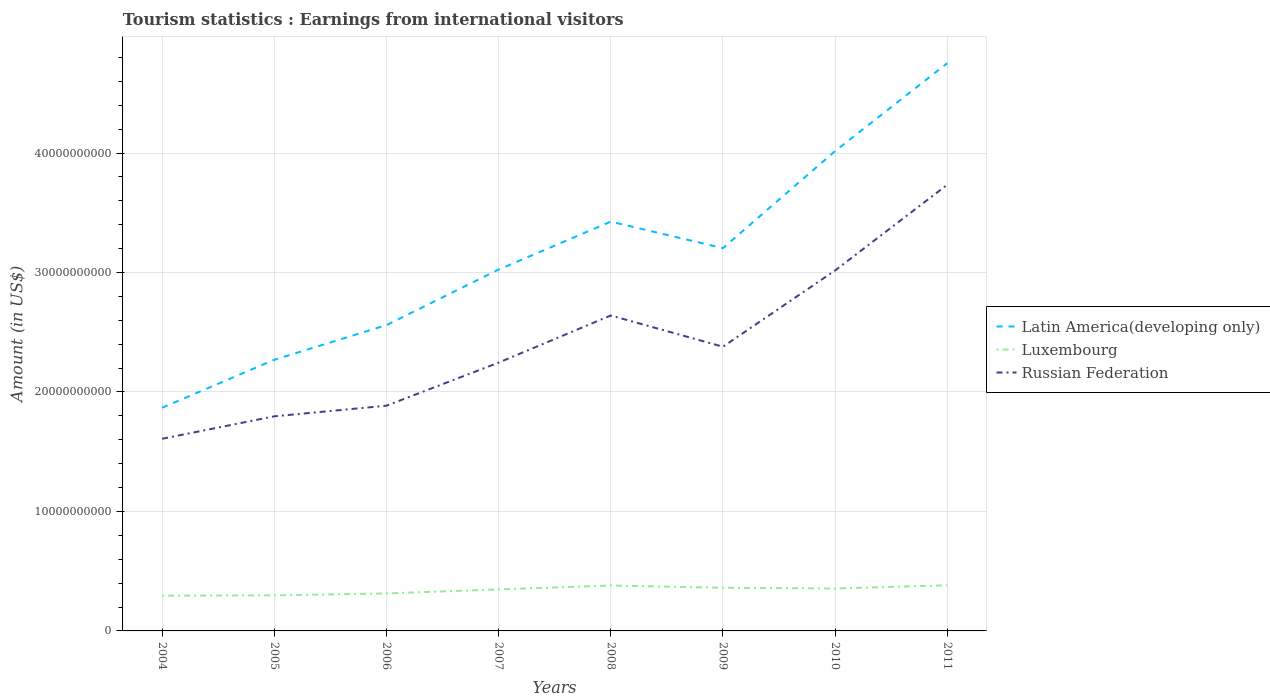How many different coloured lines are there?
Offer a terse response. 3. Across all years, what is the maximum earnings from international visitors in Luxembourg?
Keep it short and to the point. 2.95e+09. In which year was the earnings from international visitors in Russian Federation maximum?
Your answer should be compact. 2004. What is the total earnings from international visitors in Russian Federation in the graph?
Offer a terse response. -1.03e+1. What is the difference between the highest and the second highest earnings from international visitors in Latin America(developing only)?
Give a very brief answer. 2.88e+1. What is the difference between the highest and the lowest earnings from international visitors in Luxembourg?
Your answer should be compact. 5. Is the earnings from international visitors in Luxembourg strictly greater than the earnings from international visitors in Russian Federation over the years?
Offer a very short reply. Yes. How many years are there in the graph?
Offer a terse response. 8. What is the difference between two consecutive major ticks on the Y-axis?
Give a very brief answer. 1.00e+1. Does the graph contain grids?
Your answer should be very brief. Yes. How are the legend labels stacked?
Your answer should be compact. Vertical. What is the title of the graph?
Keep it short and to the point. Tourism statistics : Earnings from international visitors. Does "Andorra" appear as one of the legend labels in the graph?
Your answer should be compact. No. What is the Amount (in US$) of Latin America(developing only) in 2004?
Offer a terse response. 1.87e+1. What is the Amount (in US$) of Luxembourg in 2004?
Provide a succinct answer. 2.95e+09. What is the Amount (in US$) of Russian Federation in 2004?
Your answer should be compact. 1.61e+1. What is the Amount (in US$) in Latin America(developing only) in 2005?
Provide a short and direct response. 2.27e+1. What is the Amount (in US$) of Luxembourg in 2005?
Offer a very short reply. 2.98e+09. What is the Amount (in US$) in Russian Federation in 2005?
Provide a short and direct response. 1.80e+1. What is the Amount (in US$) of Latin America(developing only) in 2006?
Your response must be concise. 2.56e+1. What is the Amount (in US$) in Luxembourg in 2006?
Give a very brief answer. 3.14e+09. What is the Amount (in US$) in Russian Federation in 2006?
Provide a succinct answer. 1.88e+1. What is the Amount (in US$) in Latin America(developing only) in 2007?
Offer a terse response. 3.02e+1. What is the Amount (in US$) of Luxembourg in 2007?
Keep it short and to the point. 3.48e+09. What is the Amount (in US$) of Russian Federation in 2007?
Your answer should be very brief. 2.25e+1. What is the Amount (in US$) in Latin America(developing only) in 2008?
Ensure brevity in your answer.  3.43e+1. What is the Amount (in US$) of Luxembourg in 2008?
Your response must be concise. 3.80e+09. What is the Amount (in US$) of Russian Federation in 2008?
Make the answer very short. 2.64e+1. What is the Amount (in US$) of Latin America(developing only) in 2009?
Your answer should be very brief. 3.20e+1. What is the Amount (in US$) in Luxembourg in 2009?
Your answer should be very brief. 3.61e+09. What is the Amount (in US$) in Russian Federation in 2009?
Provide a succinct answer. 2.38e+1. What is the Amount (in US$) in Latin America(developing only) in 2010?
Provide a succinct answer. 4.02e+1. What is the Amount (in US$) in Luxembourg in 2010?
Your response must be concise. 3.55e+09. What is the Amount (in US$) in Russian Federation in 2010?
Your response must be concise. 3.02e+1. What is the Amount (in US$) in Latin America(developing only) in 2011?
Make the answer very short. 4.75e+1. What is the Amount (in US$) of Luxembourg in 2011?
Ensure brevity in your answer.  3.82e+09. What is the Amount (in US$) of Russian Federation in 2011?
Provide a succinct answer. 3.73e+1. Across all years, what is the maximum Amount (in US$) of Latin America(developing only)?
Provide a short and direct response. 4.75e+1. Across all years, what is the maximum Amount (in US$) in Luxembourg?
Offer a very short reply. 3.82e+09. Across all years, what is the maximum Amount (in US$) of Russian Federation?
Provide a succinct answer. 3.73e+1. Across all years, what is the minimum Amount (in US$) in Latin America(developing only)?
Your response must be concise. 1.87e+1. Across all years, what is the minimum Amount (in US$) of Luxembourg?
Provide a short and direct response. 2.95e+09. Across all years, what is the minimum Amount (in US$) of Russian Federation?
Provide a succinct answer. 1.61e+1. What is the total Amount (in US$) in Latin America(developing only) in the graph?
Your answer should be very brief. 2.51e+11. What is the total Amount (in US$) of Luxembourg in the graph?
Your answer should be very brief. 2.73e+1. What is the total Amount (in US$) of Russian Federation in the graph?
Your answer should be compact. 1.93e+11. What is the difference between the Amount (in US$) of Latin America(developing only) in 2004 and that in 2005?
Keep it short and to the point. -4.01e+09. What is the difference between the Amount (in US$) in Luxembourg in 2004 and that in 2005?
Provide a short and direct response. -2.70e+07. What is the difference between the Amount (in US$) in Russian Federation in 2004 and that in 2005?
Your answer should be very brief. -1.88e+09. What is the difference between the Amount (in US$) of Latin America(developing only) in 2004 and that in 2006?
Ensure brevity in your answer.  -6.91e+09. What is the difference between the Amount (in US$) of Luxembourg in 2004 and that in 2006?
Give a very brief answer. -1.88e+08. What is the difference between the Amount (in US$) in Russian Federation in 2004 and that in 2006?
Ensure brevity in your answer.  -2.77e+09. What is the difference between the Amount (in US$) of Latin America(developing only) in 2004 and that in 2007?
Keep it short and to the point. -1.16e+1. What is the difference between the Amount (in US$) in Luxembourg in 2004 and that in 2007?
Offer a very short reply. -5.26e+08. What is the difference between the Amount (in US$) in Russian Federation in 2004 and that in 2007?
Give a very brief answer. -6.37e+09. What is the difference between the Amount (in US$) of Latin America(developing only) in 2004 and that in 2008?
Your answer should be compact. -1.56e+1. What is the difference between the Amount (in US$) in Luxembourg in 2004 and that in 2008?
Make the answer very short. -8.51e+08. What is the difference between the Amount (in US$) in Russian Federation in 2004 and that in 2008?
Offer a terse response. -1.03e+1. What is the difference between the Amount (in US$) in Latin America(developing only) in 2004 and that in 2009?
Keep it short and to the point. -1.34e+1. What is the difference between the Amount (in US$) of Luxembourg in 2004 and that in 2009?
Give a very brief answer. -6.62e+08. What is the difference between the Amount (in US$) in Russian Federation in 2004 and that in 2009?
Offer a very short reply. -7.70e+09. What is the difference between the Amount (in US$) in Latin America(developing only) in 2004 and that in 2010?
Keep it short and to the point. -2.15e+1. What is the difference between the Amount (in US$) in Luxembourg in 2004 and that in 2010?
Your response must be concise. -5.99e+08. What is the difference between the Amount (in US$) in Russian Federation in 2004 and that in 2010?
Your answer should be compact. -1.41e+1. What is the difference between the Amount (in US$) of Latin America(developing only) in 2004 and that in 2011?
Give a very brief answer. -2.88e+1. What is the difference between the Amount (in US$) in Luxembourg in 2004 and that in 2011?
Provide a succinct answer. -8.72e+08. What is the difference between the Amount (in US$) of Russian Federation in 2004 and that in 2011?
Your answer should be compact. -2.13e+1. What is the difference between the Amount (in US$) in Latin America(developing only) in 2005 and that in 2006?
Provide a succinct answer. -2.90e+09. What is the difference between the Amount (in US$) of Luxembourg in 2005 and that in 2006?
Provide a succinct answer. -1.61e+08. What is the difference between the Amount (in US$) in Russian Federation in 2005 and that in 2006?
Provide a short and direct response. -8.87e+08. What is the difference between the Amount (in US$) in Latin America(developing only) in 2005 and that in 2007?
Give a very brief answer. -7.55e+09. What is the difference between the Amount (in US$) of Luxembourg in 2005 and that in 2007?
Offer a very short reply. -4.99e+08. What is the difference between the Amount (in US$) of Russian Federation in 2005 and that in 2007?
Ensure brevity in your answer.  -4.49e+09. What is the difference between the Amount (in US$) of Latin America(developing only) in 2005 and that in 2008?
Give a very brief answer. -1.16e+1. What is the difference between the Amount (in US$) of Luxembourg in 2005 and that in 2008?
Make the answer very short. -8.24e+08. What is the difference between the Amount (in US$) in Russian Federation in 2005 and that in 2008?
Provide a short and direct response. -8.44e+09. What is the difference between the Amount (in US$) in Latin America(developing only) in 2005 and that in 2009?
Keep it short and to the point. -9.34e+09. What is the difference between the Amount (in US$) in Luxembourg in 2005 and that in 2009?
Your answer should be compact. -6.35e+08. What is the difference between the Amount (in US$) in Russian Federation in 2005 and that in 2009?
Give a very brief answer. -5.82e+09. What is the difference between the Amount (in US$) in Latin America(developing only) in 2005 and that in 2010?
Offer a very short reply. -1.75e+1. What is the difference between the Amount (in US$) of Luxembourg in 2005 and that in 2010?
Provide a succinct answer. -5.72e+08. What is the difference between the Amount (in US$) of Russian Federation in 2005 and that in 2010?
Keep it short and to the point. -1.22e+1. What is the difference between the Amount (in US$) in Latin America(developing only) in 2005 and that in 2011?
Your answer should be compact. -2.48e+1. What is the difference between the Amount (in US$) of Luxembourg in 2005 and that in 2011?
Ensure brevity in your answer.  -8.45e+08. What is the difference between the Amount (in US$) in Russian Federation in 2005 and that in 2011?
Offer a very short reply. -1.94e+1. What is the difference between the Amount (in US$) of Latin America(developing only) in 2006 and that in 2007?
Keep it short and to the point. -4.65e+09. What is the difference between the Amount (in US$) of Luxembourg in 2006 and that in 2007?
Ensure brevity in your answer.  -3.38e+08. What is the difference between the Amount (in US$) in Russian Federation in 2006 and that in 2007?
Your response must be concise. -3.61e+09. What is the difference between the Amount (in US$) in Latin America(developing only) in 2006 and that in 2008?
Provide a succinct answer. -8.66e+09. What is the difference between the Amount (in US$) of Luxembourg in 2006 and that in 2008?
Offer a terse response. -6.63e+08. What is the difference between the Amount (in US$) in Russian Federation in 2006 and that in 2008?
Offer a terse response. -7.55e+09. What is the difference between the Amount (in US$) in Latin America(developing only) in 2006 and that in 2009?
Keep it short and to the point. -6.44e+09. What is the difference between the Amount (in US$) of Luxembourg in 2006 and that in 2009?
Make the answer very short. -4.74e+08. What is the difference between the Amount (in US$) of Russian Federation in 2006 and that in 2009?
Keep it short and to the point. -4.94e+09. What is the difference between the Amount (in US$) in Latin America(developing only) in 2006 and that in 2010?
Provide a short and direct response. -1.46e+1. What is the difference between the Amount (in US$) of Luxembourg in 2006 and that in 2010?
Provide a short and direct response. -4.11e+08. What is the difference between the Amount (in US$) of Russian Federation in 2006 and that in 2010?
Give a very brief answer. -1.13e+1. What is the difference between the Amount (in US$) in Latin America(developing only) in 2006 and that in 2011?
Give a very brief answer. -2.19e+1. What is the difference between the Amount (in US$) of Luxembourg in 2006 and that in 2011?
Offer a terse response. -6.84e+08. What is the difference between the Amount (in US$) of Russian Federation in 2006 and that in 2011?
Your answer should be very brief. -1.85e+1. What is the difference between the Amount (in US$) in Latin America(developing only) in 2007 and that in 2008?
Your response must be concise. -4.01e+09. What is the difference between the Amount (in US$) of Luxembourg in 2007 and that in 2008?
Make the answer very short. -3.25e+08. What is the difference between the Amount (in US$) of Russian Federation in 2007 and that in 2008?
Offer a terse response. -3.94e+09. What is the difference between the Amount (in US$) in Latin America(developing only) in 2007 and that in 2009?
Ensure brevity in your answer.  -1.79e+09. What is the difference between the Amount (in US$) in Luxembourg in 2007 and that in 2009?
Offer a very short reply. -1.36e+08. What is the difference between the Amount (in US$) in Russian Federation in 2007 and that in 2009?
Offer a terse response. -1.33e+09. What is the difference between the Amount (in US$) of Latin America(developing only) in 2007 and that in 2010?
Offer a terse response. -9.91e+09. What is the difference between the Amount (in US$) of Luxembourg in 2007 and that in 2010?
Keep it short and to the point. -7.30e+07. What is the difference between the Amount (in US$) of Russian Federation in 2007 and that in 2010?
Make the answer very short. -7.71e+09. What is the difference between the Amount (in US$) in Latin America(developing only) in 2007 and that in 2011?
Give a very brief answer. -1.73e+1. What is the difference between the Amount (in US$) in Luxembourg in 2007 and that in 2011?
Keep it short and to the point. -3.46e+08. What is the difference between the Amount (in US$) in Russian Federation in 2007 and that in 2011?
Your response must be concise. -1.49e+1. What is the difference between the Amount (in US$) in Latin America(developing only) in 2008 and that in 2009?
Provide a succinct answer. 2.22e+09. What is the difference between the Amount (in US$) of Luxembourg in 2008 and that in 2009?
Your answer should be compact. 1.89e+08. What is the difference between the Amount (in US$) in Russian Federation in 2008 and that in 2009?
Give a very brief answer. 2.62e+09. What is the difference between the Amount (in US$) in Latin America(developing only) in 2008 and that in 2010?
Your response must be concise. -5.90e+09. What is the difference between the Amount (in US$) in Luxembourg in 2008 and that in 2010?
Your response must be concise. 2.52e+08. What is the difference between the Amount (in US$) in Russian Federation in 2008 and that in 2010?
Give a very brief answer. -3.77e+09. What is the difference between the Amount (in US$) in Latin America(developing only) in 2008 and that in 2011?
Offer a terse response. -1.33e+1. What is the difference between the Amount (in US$) in Luxembourg in 2008 and that in 2011?
Offer a terse response. -2.10e+07. What is the difference between the Amount (in US$) in Russian Federation in 2008 and that in 2011?
Your answer should be very brief. -1.09e+1. What is the difference between the Amount (in US$) in Latin America(developing only) in 2009 and that in 2010?
Offer a terse response. -8.12e+09. What is the difference between the Amount (in US$) of Luxembourg in 2009 and that in 2010?
Offer a very short reply. 6.30e+07. What is the difference between the Amount (in US$) in Russian Federation in 2009 and that in 2010?
Provide a succinct answer. -6.38e+09. What is the difference between the Amount (in US$) of Latin America(developing only) in 2009 and that in 2011?
Provide a succinct answer. -1.55e+1. What is the difference between the Amount (in US$) of Luxembourg in 2009 and that in 2011?
Give a very brief answer. -2.10e+08. What is the difference between the Amount (in US$) of Russian Federation in 2009 and that in 2011?
Offer a very short reply. -1.36e+1. What is the difference between the Amount (in US$) of Latin America(developing only) in 2010 and that in 2011?
Ensure brevity in your answer.  -7.36e+09. What is the difference between the Amount (in US$) of Luxembourg in 2010 and that in 2011?
Make the answer very short. -2.73e+08. What is the difference between the Amount (in US$) in Russian Federation in 2010 and that in 2011?
Give a very brief answer. -7.17e+09. What is the difference between the Amount (in US$) in Latin America(developing only) in 2004 and the Amount (in US$) in Luxembourg in 2005?
Your response must be concise. 1.57e+1. What is the difference between the Amount (in US$) of Latin America(developing only) in 2004 and the Amount (in US$) of Russian Federation in 2005?
Make the answer very short. 7.19e+08. What is the difference between the Amount (in US$) in Luxembourg in 2004 and the Amount (in US$) in Russian Federation in 2005?
Provide a succinct answer. -1.50e+1. What is the difference between the Amount (in US$) of Latin America(developing only) in 2004 and the Amount (in US$) of Luxembourg in 2006?
Make the answer very short. 1.55e+1. What is the difference between the Amount (in US$) in Latin America(developing only) in 2004 and the Amount (in US$) in Russian Federation in 2006?
Provide a succinct answer. -1.68e+08. What is the difference between the Amount (in US$) in Luxembourg in 2004 and the Amount (in US$) in Russian Federation in 2006?
Your response must be concise. -1.59e+1. What is the difference between the Amount (in US$) of Latin America(developing only) in 2004 and the Amount (in US$) of Luxembourg in 2007?
Make the answer very short. 1.52e+1. What is the difference between the Amount (in US$) of Latin America(developing only) in 2004 and the Amount (in US$) of Russian Federation in 2007?
Ensure brevity in your answer.  -3.77e+09. What is the difference between the Amount (in US$) of Luxembourg in 2004 and the Amount (in US$) of Russian Federation in 2007?
Ensure brevity in your answer.  -1.95e+1. What is the difference between the Amount (in US$) of Latin America(developing only) in 2004 and the Amount (in US$) of Luxembourg in 2008?
Your answer should be compact. 1.49e+1. What is the difference between the Amount (in US$) in Latin America(developing only) in 2004 and the Amount (in US$) in Russian Federation in 2008?
Offer a very short reply. -7.72e+09. What is the difference between the Amount (in US$) in Luxembourg in 2004 and the Amount (in US$) in Russian Federation in 2008?
Provide a short and direct response. -2.35e+1. What is the difference between the Amount (in US$) of Latin America(developing only) in 2004 and the Amount (in US$) of Luxembourg in 2009?
Your response must be concise. 1.51e+1. What is the difference between the Amount (in US$) in Latin America(developing only) in 2004 and the Amount (in US$) in Russian Federation in 2009?
Offer a very short reply. -5.10e+09. What is the difference between the Amount (in US$) in Luxembourg in 2004 and the Amount (in US$) in Russian Federation in 2009?
Make the answer very short. -2.08e+1. What is the difference between the Amount (in US$) in Latin America(developing only) in 2004 and the Amount (in US$) in Luxembourg in 2010?
Provide a succinct answer. 1.51e+1. What is the difference between the Amount (in US$) in Latin America(developing only) in 2004 and the Amount (in US$) in Russian Federation in 2010?
Provide a short and direct response. -1.15e+1. What is the difference between the Amount (in US$) in Luxembourg in 2004 and the Amount (in US$) in Russian Federation in 2010?
Make the answer very short. -2.72e+1. What is the difference between the Amount (in US$) in Latin America(developing only) in 2004 and the Amount (in US$) in Luxembourg in 2011?
Keep it short and to the point. 1.49e+1. What is the difference between the Amount (in US$) of Latin America(developing only) in 2004 and the Amount (in US$) of Russian Federation in 2011?
Your answer should be very brief. -1.87e+1. What is the difference between the Amount (in US$) of Luxembourg in 2004 and the Amount (in US$) of Russian Federation in 2011?
Your answer should be very brief. -3.44e+1. What is the difference between the Amount (in US$) of Latin America(developing only) in 2005 and the Amount (in US$) of Luxembourg in 2006?
Ensure brevity in your answer.  1.96e+1. What is the difference between the Amount (in US$) of Latin America(developing only) in 2005 and the Amount (in US$) of Russian Federation in 2006?
Keep it short and to the point. 3.84e+09. What is the difference between the Amount (in US$) in Luxembourg in 2005 and the Amount (in US$) in Russian Federation in 2006?
Offer a terse response. -1.59e+1. What is the difference between the Amount (in US$) in Latin America(developing only) in 2005 and the Amount (in US$) in Luxembourg in 2007?
Your response must be concise. 1.92e+1. What is the difference between the Amount (in US$) in Latin America(developing only) in 2005 and the Amount (in US$) in Russian Federation in 2007?
Provide a short and direct response. 2.37e+08. What is the difference between the Amount (in US$) in Luxembourg in 2005 and the Amount (in US$) in Russian Federation in 2007?
Your response must be concise. -1.95e+1. What is the difference between the Amount (in US$) in Latin America(developing only) in 2005 and the Amount (in US$) in Luxembourg in 2008?
Ensure brevity in your answer.  1.89e+1. What is the difference between the Amount (in US$) of Latin America(developing only) in 2005 and the Amount (in US$) of Russian Federation in 2008?
Ensure brevity in your answer.  -3.71e+09. What is the difference between the Amount (in US$) in Luxembourg in 2005 and the Amount (in US$) in Russian Federation in 2008?
Your answer should be very brief. -2.34e+1. What is the difference between the Amount (in US$) of Latin America(developing only) in 2005 and the Amount (in US$) of Luxembourg in 2009?
Your answer should be very brief. 1.91e+1. What is the difference between the Amount (in US$) of Latin America(developing only) in 2005 and the Amount (in US$) of Russian Federation in 2009?
Your answer should be compact. -1.09e+09. What is the difference between the Amount (in US$) in Luxembourg in 2005 and the Amount (in US$) in Russian Federation in 2009?
Offer a terse response. -2.08e+1. What is the difference between the Amount (in US$) of Latin America(developing only) in 2005 and the Amount (in US$) of Luxembourg in 2010?
Your answer should be compact. 1.91e+1. What is the difference between the Amount (in US$) in Latin America(developing only) in 2005 and the Amount (in US$) in Russian Federation in 2010?
Offer a very short reply. -7.48e+09. What is the difference between the Amount (in US$) in Luxembourg in 2005 and the Amount (in US$) in Russian Federation in 2010?
Ensure brevity in your answer.  -2.72e+1. What is the difference between the Amount (in US$) in Latin America(developing only) in 2005 and the Amount (in US$) in Luxembourg in 2011?
Make the answer very short. 1.89e+1. What is the difference between the Amount (in US$) in Latin America(developing only) in 2005 and the Amount (in US$) in Russian Federation in 2011?
Keep it short and to the point. -1.46e+1. What is the difference between the Amount (in US$) in Luxembourg in 2005 and the Amount (in US$) in Russian Federation in 2011?
Make the answer very short. -3.44e+1. What is the difference between the Amount (in US$) in Latin America(developing only) in 2006 and the Amount (in US$) in Luxembourg in 2007?
Ensure brevity in your answer.  2.21e+1. What is the difference between the Amount (in US$) of Latin America(developing only) in 2006 and the Amount (in US$) of Russian Federation in 2007?
Keep it short and to the point. 3.14e+09. What is the difference between the Amount (in US$) in Luxembourg in 2006 and the Amount (in US$) in Russian Federation in 2007?
Provide a succinct answer. -1.93e+1. What is the difference between the Amount (in US$) of Latin America(developing only) in 2006 and the Amount (in US$) of Luxembourg in 2008?
Your response must be concise. 2.18e+1. What is the difference between the Amount (in US$) of Latin America(developing only) in 2006 and the Amount (in US$) of Russian Federation in 2008?
Give a very brief answer. -8.07e+08. What is the difference between the Amount (in US$) in Luxembourg in 2006 and the Amount (in US$) in Russian Federation in 2008?
Give a very brief answer. -2.33e+1. What is the difference between the Amount (in US$) of Latin America(developing only) in 2006 and the Amount (in US$) of Luxembourg in 2009?
Give a very brief answer. 2.20e+1. What is the difference between the Amount (in US$) of Latin America(developing only) in 2006 and the Amount (in US$) of Russian Federation in 2009?
Your answer should be very brief. 1.81e+09. What is the difference between the Amount (in US$) in Luxembourg in 2006 and the Amount (in US$) in Russian Federation in 2009?
Give a very brief answer. -2.06e+1. What is the difference between the Amount (in US$) of Latin America(developing only) in 2006 and the Amount (in US$) of Luxembourg in 2010?
Keep it short and to the point. 2.20e+1. What is the difference between the Amount (in US$) in Latin America(developing only) in 2006 and the Amount (in US$) in Russian Federation in 2010?
Provide a succinct answer. -4.58e+09. What is the difference between the Amount (in US$) in Luxembourg in 2006 and the Amount (in US$) in Russian Federation in 2010?
Offer a very short reply. -2.70e+1. What is the difference between the Amount (in US$) in Latin America(developing only) in 2006 and the Amount (in US$) in Luxembourg in 2011?
Offer a terse response. 2.18e+1. What is the difference between the Amount (in US$) of Latin America(developing only) in 2006 and the Amount (in US$) of Russian Federation in 2011?
Your response must be concise. -1.17e+1. What is the difference between the Amount (in US$) in Luxembourg in 2006 and the Amount (in US$) in Russian Federation in 2011?
Your answer should be compact. -3.42e+1. What is the difference between the Amount (in US$) in Latin America(developing only) in 2007 and the Amount (in US$) in Luxembourg in 2008?
Provide a short and direct response. 2.64e+1. What is the difference between the Amount (in US$) in Latin America(developing only) in 2007 and the Amount (in US$) in Russian Federation in 2008?
Offer a very short reply. 3.84e+09. What is the difference between the Amount (in US$) in Luxembourg in 2007 and the Amount (in US$) in Russian Federation in 2008?
Offer a very short reply. -2.29e+1. What is the difference between the Amount (in US$) in Latin America(developing only) in 2007 and the Amount (in US$) in Luxembourg in 2009?
Your answer should be very brief. 2.66e+1. What is the difference between the Amount (in US$) in Latin America(developing only) in 2007 and the Amount (in US$) in Russian Federation in 2009?
Offer a very short reply. 6.46e+09. What is the difference between the Amount (in US$) of Luxembourg in 2007 and the Amount (in US$) of Russian Federation in 2009?
Your answer should be very brief. -2.03e+1. What is the difference between the Amount (in US$) of Latin America(developing only) in 2007 and the Amount (in US$) of Luxembourg in 2010?
Your answer should be compact. 2.67e+1. What is the difference between the Amount (in US$) in Latin America(developing only) in 2007 and the Amount (in US$) in Russian Federation in 2010?
Provide a short and direct response. 7.63e+07. What is the difference between the Amount (in US$) of Luxembourg in 2007 and the Amount (in US$) of Russian Federation in 2010?
Make the answer very short. -2.67e+1. What is the difference between the Amount (in US$) in Latin America(developing only) in 2007 and the Amount (in US$) in Luxembourg in 2011?
Make the answer very short. 2.64e+1. What is the difference between the Amount (in US$) of Latin America(developing only) in 2007 and the Amount (in US$) of Russian Federation in 2011?
Keep it short and to the point. -7.10e+09. What is the difference between the Amount (in US$) in Luxembourg in 2007 and the Amount (in US$) in Russian Federation in 2011?
Provide a short and direct response. -3.39e+1. What is the difference between the Amount (in US$) of Latin America(developing only) in 2008 and the Amount (in US$) of Luxembourg in 2009?
Give a very brief answer. 3.06e+1. What is the difference between the Amount (in US$) in Latin America(developing only) in 2008 and the Amount (in US$) in Russian Federation in 2009?
Your answer should be compact. 1.05e+1. What is the difference between the Amount (in US$) in Luxembourg in 2008 and the Amount (in US$) in Russian Federation in 2009?
Your answer should be compact. -2.00e+1. What is the difference between the Amount (in US$) of Latin America(developing only) in 2008 and the Amount (in US$) of Luxembourg in 2010?
Your response must be concise. 3.07e+1. What is the difference between the Amount (in US$) of Latin America(developing only) in 2008 and the Amount (in US$) of Russian Federation in 2010?
Your answer should be very brief. 4.09e+09. What is the difference between the Amount (in US$) of Luxembourg in 2008 and the Amount (in US$) of Russian Federation in 2010?
Keep it short and to the point. -2.64e+1. What is the difference between the Amount (in US$) in Latin America(developing only) in 2008 and the Amount (in US$) in Luxembourg in 2011?
Your response must be concise. 3.04e+1. What is the difference between the Amount (in US$) of Latin America(developing only) in 2008 and the Amount (in US$) of Russian Federation in 2011?
Your answer should be compact. -3.09e+09. What is the difference between the Amount (in US$) of Luxembourg in 2008 and the Amount (in US$) of Russian Federation in 2011?
Your answer should be very brief. -3.35e+1. What is the difference between the Amount (in US$) of Latin America(developing only) in 2009 and the Amount (in US$) of Luxembourg in 2010?
Offer a terse response. 2.85e+1. What is the difference between the Amount (in US$) of Latin America(developing only) in 2009 and the Amount (in US$) of Russian Federation in 2010?
Provide a short and direct response. 1.87e+09. What is the difference between the Amount (in US$) in Luxembourg in 2009 and the Amount (in US$) in Russian Federation in 2010?
Offer a very short reply. -2.66e+1. What is the difference between the Amount (in US$) in Latin America(developing only) in 2009 and the Amount (in US$) in Luxembourg in 2011?
Offer a very short reply. 2.82e+1. What is the difference between the Amount (in US$) in Latin America(developing only) in 2009 and the Amount (in US$) in Russian Federation in 2011?
Your answer should be very brief. -5.31e+09. What is the difference between the Amount (in US$) in Luxembourg in 2009 and the Amount (in US$) in Russian Federation in 2011?
Your answer should be compact. -3.37e+1. What is the difference between the Amount (in US$) in Latin America(developing only) in 2010 and the Amount (in US$) in Luxembourg in 2011?
Keep it short and to the point. 3.63e+1. What is the difference between the Amount (in US$) in Latin America(developing only) in 2010 and the Amount (in US$) in Russian Federation in 2011?
Offer a very short reply. 2.82e+09. What is the difference between the Amount (in US$) in Luxembourg in 2010 and the Amount (in US$) in Russian Federation in 2011?
Make the answer very short. -3.38e+1. What is the average Amount (in US$) of Latin America(developing only) per year?
Give a very brief answer. 3.14e+1. What is the average Amount (in US$) of Luxembourg per year?
Your response must be concise. 3.42e+09. What is the average Amount (in US$) in Russian Federation per year?
Your response must be concise. 2.41e+1. In the year 2004, what is the difference between the Amount (in US$) in Latin America(developing only) and Amount (in US$) in Luxembourg?
Give a very brief answer. 1.57e+1. In the year 2004, what is the difference between the Amount (in US$) of Latin America(developing only) and Amount (in US$) of Russian Federation?
Ensure brevity in your answer.  2.60e+09. In the year 2004, what is the difference between the Amount (in US$) of Luxembourg and Amount (in US$) of Russian Federation?
Make the answer very short. -1.31e+1. In the year 2005, what is the difference between the Amount (in US$) in Latin America(developing only) and Amount (in US$) in Luxembourg?
Provide a succinct answer. 1.97e+1. In the year 2005, what is the difference between the Amount (in US$) of Latin America(developing only) and Amount (in US$) of Russian Federation?
Give a very brief answer. 4.73e+09. In the year 2005, what is the difference between the Amount (in US$) in Luxembourg and Amount (in US$) in Russian Federation?
Your answer should be compact. -1.50e+1. In the year 2006, what is the difference between the Amount (in US$) of Latin America(developing only) and Amount (in US$) of Luxembourg?
Ensure brevity in your answer.  2.25e+1. In the year 2006, what is the difference between the Amount (in US$) of Latin America(developing only) and Amount (in US$) of Russian Federation?
Provide a short and direct response. 6.74e+09. In the year 2006, what is the difference between the Amount (in US$) of Luxembourg and Amount (in US$) of Russian Federation?
Your answer should be very brief. -1.57e+1. In the year 2007, what is the difference between the Amount (in US$) of Latin America(developing only) and Amount (in US$) of Luxembourg?
Ensure brevity in your answer.  2.68e+1. In the year 2007, what is the difference between the Amount (in US$) of Latin America(developing only) and Amount (in US$) of Russian Federation?
Offer a very short reply. 7.79e+09. In the year 2007, what is the difference between the Amount (in US$) of Luxembourg and Amount (in US$) of Russian Federation?
Your answer should be very brief. -1.90e+1. In the year 2008, what is the difference between the Amount (in US$) in Latin America(developing only) and Amount (in US$) in Luxembourg?
Give a very brief answer. 3.05e+1. In the year 2008, what is the difference between the Amount (in US$) in Latin America(developing only) and Amount (in US$) in Russian Federation?
Offer a very short reply. 7.85e+09. In the year 2008, what is the difference between the Amount (in US$) in Luxembourg and Amount (in US$) in Russian Federation?
Offer a terse response. -2.26e+1. In the year 2009, what is the difference between the Amount (in US$) of Latin America(developing only) and Amount (in US$) of Luxembourg?
Ensure brevity in your answer.  2.84e+1. In the year 2009, what is the difference between the Amount (in US$) of Latin America(developing only) and Amount (in US$) of Russian Federation?
Your answer should be compact. 8.25e+09. In the year 2009, what is the difference between the Amount (in US$) of Luxembourg and Amount (in US$) of Russian Federation?
Ensure brevity in your answer.  -2.02e+1. In the year 2010, what is the difference between the Amount (in US$) in Latin America(developing only) and Amount (in US$) in Luxembourg?
Keep it short and to the point. 3.66e+1. In the year 2010, what is the difference between the Amount (in US$) in Latin America(developing only) and Amount (in US$) in Russian Federation?
Offer a very short reply. 9.99e+09. In the year 2010, what is the difference between the Amount (in US$) of Luxembourg and Amount (in US$) of Russian Federation?
Make the answer very short. -2.66e+1. In the year 2011, what is the difference between the Amount (in US$) in Latin America(developing only) and Amount (in US$) in Luxembourg?
Give a very brief answer. 4.37e+1. In the year 2011, what is the difference between the Amount (in US$) in Latin America(developing only) and Amount (in US$) in Russian Federation?
Give a very brief answer. 1.02e+1. In the year 2011, what is the difference between the Amount (in US$) of Luxembourg and Amount (in US$) of Russian Federation?
Give a very brief answer. -3.35e+1. What is the ratio of the Amount (in US$) of Latin America(developing only) in 2004 to that in 2005?
Provide a short and direct response. 0.82. What is the ratio of the Amount (in US$) of Luxembourg in 2004 to that in 2005?
Ensure brevity in your answer.  0.99. What is the ratio of the Amount (in US$) in Russian Federation in 2004 to that in 2005?
Offer a very short reply. 0.9. What is the ratio of the Amount (in US$) of Latin America(developing only) in 2004 to that in 2006?
Provide a short and direct response. 0.73. What is the ratio of the Amount (in US$) in Luxembourg in 2004 to that in 2006?
Your answer should be very brief. 0.94. What is the ratio of the Amount (in US$) of Russian Federation in 2004 to that in 2006?
Your response must be concise. 0.85. What is the ratio of the Amount (in US$) in Latin America(developing only) in 2004 to that in 2007?
Offer a terse response. 0.62. What is the ratio of the Amount (in US$) of Luxembourg in 2004 to that in 2007?
Your response must be concise. 0.85. What is the ratio of the Amount (in US$) of Russian Federation in 2004 to that in 2007?
Your answer should be compact. 0.72. What is the ratio of the Amount (in US$) in Latin America(developing only) in 2004 to that in 2008?
Provide a short and direct response. 0.55. What is the ratio of the Amount (in US$) of Luxembourg in 2004 to that in 2008?
Offer a terse response. 0.78. What is the ratio of the Amount (in US$) in Russian Federation in 2004 to that in 2008?
Provide a succinct answer. 0.61. What is the ratio of the Amount (in US$) in Latin America(developing only) in 2004 to that in 2009?
Your answer should be very brief. 0.58. What is the ratio of the Amount (in US$) of Luxembourg in 2004 to that in 2009?
Provide a succinct answer. 0.82. What is the ratio of the Amount (in US$) of Russian Federation in 2004 to that in 2009?
Provide a short and direct response. 0.68. What is the ratio of the Amount (in US$) of Latin America(developing only) in 2004 to that in 2010?
Ensure brevity in your answer.  0.47. What is the ratio of the Amount (in US$) in Luxembourg in 2004 to that in 2010?
Make the answer very short. 0.83. What is the ratio of the Amount (in US$) in Russian Federation in 2004 to that in 2010?
Your answer should be very brief. 0.53. What is the ratio of the Amount (in US$) of Latin America(developing only) in 2004 to that in 2011?
Your response must be concise. 0.39. What is the ratio of the Amount (in US$) in Luxembourg in 2004 to that in 2011?
Keep it short and to the point. 0.77. What is the ratio of the Amount (in US$) in Russian Federation in 2004 to that in 2011?
Make the answer very short. 0.43. What is the ratio of the Amount (in US$) of Latin America(developing only) in 2005 to that in 2006?
Keep it short and to the point. 0.89. What is the ratio of the Amount (in US$) of Luxembourg in 2005 to that in 2006?
Your answer should be very brief. 0.95. What is the ratio of the Amount (in US$) of Russian Federation in 2005 to that in 2006?
Offer a terse response. 0.95. What is the ratio of the Amount (in US$) in Latin America(developing only) in 2005 to that in 2007?
Ensure brevity in your answer.  0.75. What is the ratio of the Amount (in US$) of Luxembourg in 2005 to that in 2007?
Offer a very short reply. 0.86. What is the ratio of the Amount (in US$) of Russian Federation in 2005 to that in 2007?
Your answer should be compact. 0.8. What is the ratio of the Amount (in US$) in Latin America(developing only) in 2005 to that in 2008?
Your response must be concise. 0.66. What is the ratio of the Amount (in US$) of Luxembourg in 2005 to that in 2008?
Offer a very short reply. 0.78. What is the ratio of the Amount (in US$) of Russian Federation in 2005 to that in 2008?
Provide a short and direct response. 0.68. What is the ratio of the Amount (in US$) of Latin America(developing only) in 2005 to that in 2009?
Provide a succinct answer. 0.71. What is the ratio of the Amount (in US$) in Luxembourg in 2005 to that in 2009?
Provide a short and direct response. 0.82. What is the ratio of the Amount (in US$) in Russian Federation in 2005 to that in 2009?
Keep it short and to the point. 0.76. What is the ratio of the Amount (in US$) of Latin America(developing only) in 2005 to that in 2010?
Your response must be concise. 0.57. What is the ratio of the Amount (in US$) in Luxembourg in 2005 to that in 2010?
Your answer should be compact. 0.84. What is the ratio of the Amount (in US$) in Russian Federation in 2005 to that in 2010?
Give a very brief answer. 0.6. What is the ratio of the Amount (in US$) in Latin America(developing only) in 2005 to that in 2011?
Give a very brief answer. 0.48. What is the ratio of the Amount (in US$) in Luxembourg in 2005 to that in 2011?
Keep it short and to the point. 0.78. What is the ratio of the Amount (in US$) in Russian Federation in 2005 to that in 2011?
Offer a very short reply. 0.48. What is the ratio of the Amount (in US$) of Latin America(developing only) in 2006 to that in 2007?
Provide a succinct answer. 0.85. What is the ratio of the Amount (in US$) of Luxembourg in 2006 to that in 2007?
Offer a terse response. 0.9. What is the ratio of the Amount (in US$) of Russian Federation in 2006 to that in 2007?
Your answer should be compact. 0.84. What is the ratio of the Amount (in US$) in Latin America(developing only) in 2006 to that in 2008?
Keep it short and to the point. 0.75. What is the ratio of the Amount (in US$) of Luxembourg in 2006 to that in 2008?
Give a very brief answer. 0.83. What is the ratio of the Amount (in US$) of Russian Federation in 2006 to that in 2008?
Provide a succinct answer. 0.71. What is the ratio of the Amount (in US$) in Latin America(developing only) in 2006 to that in 2009?
Keep it short and to the point. 0.8. What is the ratio of the Amount (in US$) in Luxembourg in 2006 to that in 2009?
Provide a succinct answer. 0.87. What is the ratio of the Amount (in US$) of Russian Federation in 2006 to that in 2009?
Offer a very short reply. 0.79. What is the ratio of the Amount (in US$) in Latin America(developing only) in 2006 to that in 2010?
Your answer should be very brief. 0.64. What is the ratio of the Amount (in US$) of Luxembourg in 2006 to that in 2010?
Your response must be concise. 0.88. What is the ratio of the Amount (in US$) of Russian Federation in 2006 to that in 2010?
Offer a terse response. 0.62. What is the ratio of the Amount (in US$) of Latin America(developing only) in 2006 to that in 2011?
Offer a terse response. 0.54. What is the ratio of the Amount (in US$) in Luxembourg in 2006 to that in 2011?
Keep it short and to the point. 0.82. What is the ratio of the Amount (in US$) of Russian Federation in 2006 to that in 2011?
Your answer should be very brief. 0.5. What is the ratio of the Amount (in US$) of Latin America(developing only) in 2007 to that in 2008?
Your response must be concise. 0.88. What is the ratio of the Amount (in US$) of Luxembourg in 2007 to that in 2008?
Offer a very short reply. 0.91. What is the ratio of the Amount (in US$) of Russian Federation in 2007 to that in 2008?
Offer a terse response. 0.85. What is the ratio of the Amount (in US$) in Latin America(developing only) in 2007 to that in 2009?
Offer a terse response. 0.94. What is the ratio of the Amount (in US$) of Luxembourg in 2007 to that in 2009?
Provide a short and direct response. 0.96. What is the ratio of the Amount (in US$) in Russian Federation in 2007 to that in 2009?
Ensure brevity in your answer.  0.94. What is the ratio of the Amount (in US$) of Latin America(developing only) in 2007 to that in 2010?
Offer a terse response. 0.75. What is the ratio of the Amount (in US$) in Luxembourg in 2007 to that in 2010?
Give a very brief answer. 0.98. What is the ratio of the Amount (in US$) of Russian Federation in 2007 to that in 2010?
Offer a terse response. 0.74. What is the ratio of the Amount (in US$) of Latin America(developing only) in 2007 to that in 2011?
Keep it short and to the point. 0.64. What is the ratio of the Amount (in US$) in Luxembourg in 2007 to that in 2011?
Give a very brief answer. 0.91. What is the ratio of the Amount (in US$) in Russian Federation in 2007 to that in 2011?
Keep it short and to the point. 0.6. What is the ratio of the Amount (in US$) of Latin America(developing only) in 2008 to that in 2009?
Offer a terse response. 1.07. What is the ratio of the Amount (in US$) of Luxembourg in 2008 to that in 2009?
Your answer should be very brief. 1.05. What is the ratio of the Amount (in US$) in Russian Federation in 2008 to that in 2009?
Offer a terse response. 1.11. What is the ratio of the Amount (in US$) in Latin America(developing only) in 2008 to that in 2010?
Make the answer very short. 0.85. What is the ratio of the Amount (in US$) in Luxembourg in 2008 to that in 2010?
Offer a terse response. 1.07. What is the ratio of the Amount (in US$) in Russian Federation in 2008 to that in 2010?
Provide a succinct answer. 0.88. What is the ratio of the Amount (in US$) in Latin America(developing only) in 2008 to that in 2011?
Make the answer very short. 0.72. What is the ratio of the Amount (in US$) of Russian Federation in 2008 to that in 2011?
Your response must be concise. 0.71. What is the ratio of the Amount (in US$) of Latin America(developing only) in 2009 to that in 2010?
Ensure brevity in your answer.  0.8. What is the ratio of the Amount (in US$) in Luxembourg in 2009 to that in 2010?
Provide a succinct answer. 1.02. What is the ratio of the Amount (in US$) of Russian Federation in 2009 to that in 2010?
Ensure brevity in your answer.  0.79. What is the ratio of the Amount (in US$) in Latin America(developing only) in 2009 to that in 2011?
Make the answer very short. 0.67. What is the ratio of the Amount (in US$) of Luxembourg in 2009 to that in 2011?
Your answer should be very brief. 0.95. What is the ratio of the Amount (in US$) in Russian Federation in 2009 to that in 2011?
Ensure brevity in your answer.  0.64. What is the ratio of the Amount (in US$) in Latin America(developing only) in 2010 to that in 2011?
Ensure brevity in your answer.  0.85. What is the ratio of the Amount (in US$) of Russian Federation in 2010 to that in 2011?
Ensure brevity in your answer.  0.81. What is the difference between the highest and the second highest Amount (in US$) of Latin America(developing only)?
Ensure brevity in your answer.  7.36e+09. What is the difference between the highest and the second highest Amount (in US$) in Luxembourg?
Provide a succinct answer. 2.10e+07. What is the difference between the highest and the second highest Amount (in US$) of Russian Federation?
Give a very brief answer. 7.17e+09. What is the difference between the highest and the lowest Amount (in US$) of Latin America(developing only)?
Your response must be concise. 2.88e+1. What is the difference between the highest and the lowest Amount (in US$) in Luxembourg?
Ensure brevity in your answer.  8.72e+08. What is the difference between the highest and the lowest Amount (in US$) in Russian Federation?
Ensure brevity in your answer.  2.13e+1. 